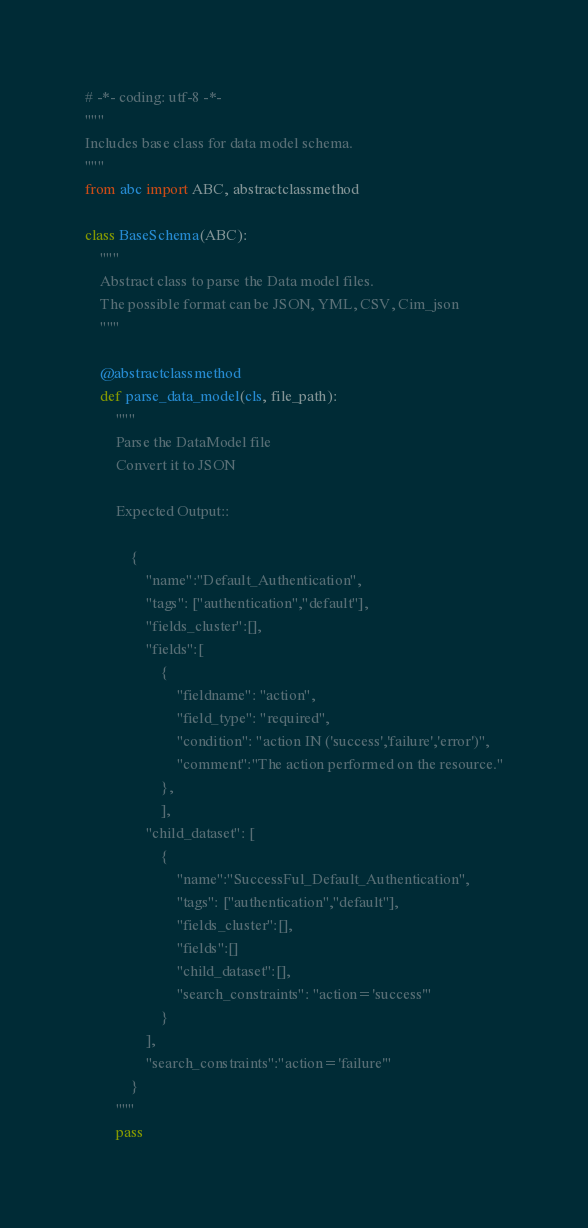<code> <loc_0><loc_0><loc_500><loc_500><_Python_># -*- coding: utf-8 -*-
"""
Includes base class for data model schema. 
"""
from abc import ABC, abstractclassmethod

class BaseSchema(ABC):
    """
    Abstract class to parse the Data model files. 
    The possible format can be JSON, YML, CSV, Cim_json
    """

    @abstractclassmethod
    def parse_data_model(cls, file_path):
        """
        Parse the DataModel file
        Convert it to JSON

        Expected Output::

            {
                "name":"Default_Authentication",
                "tags": ["authentication","default"],
                "fields_cluster":[],     
                "fields":[
                    {     
                        "fieldname": "action",     
                        "field_type": "required",    
                        "condition": "action IN ('success','failure','error')",
                        "comment":"The action performed on the resource."
                    },
                    ],
                "child_dataset": [
                    {
                        "name":"SuccessFul_Default_Authentication",
                        "tags": ["authentication","default"],
                        "fields_cluster":[],
                        "fields":[]
                        "child_dataset":[],
                        "search_constraints": "action='success'"
                    }
                ],
                "search_constraints":"action='failure'"
            }
        """
        pass
</code> 